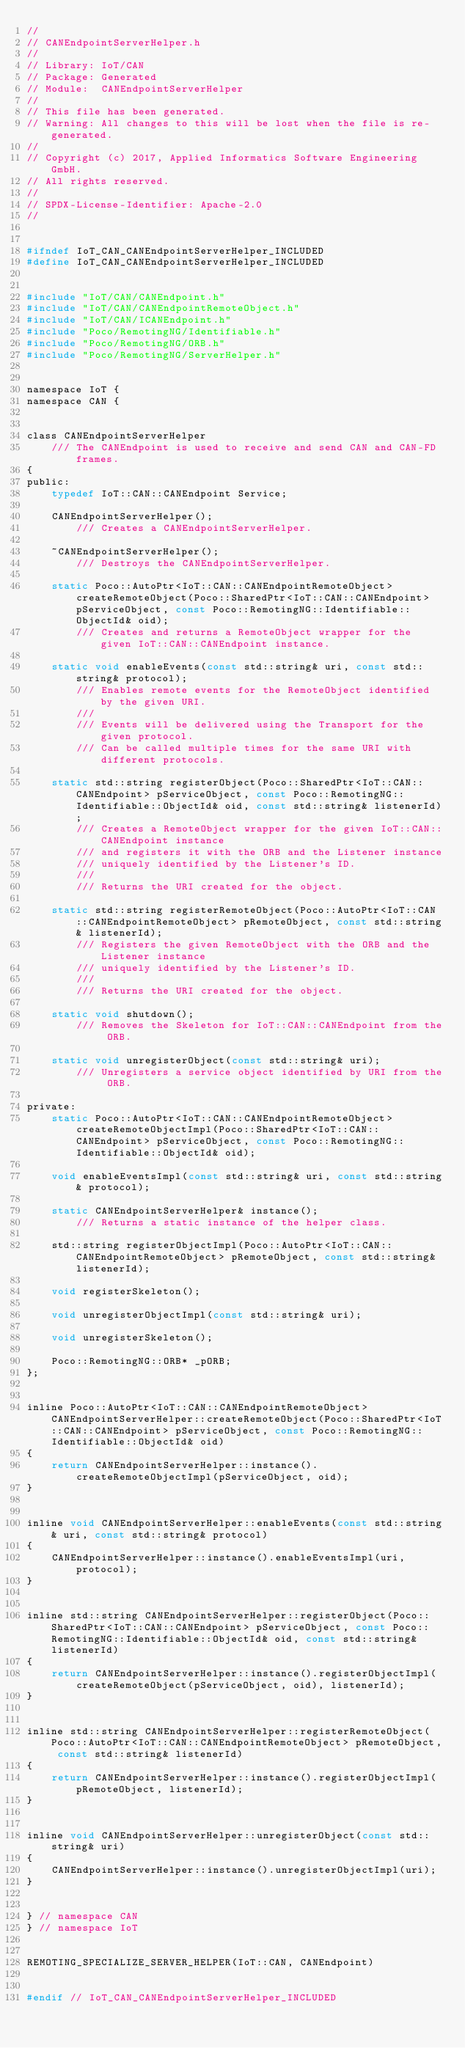<code> <loc_0><loc_0><loc_500><loc_500><_C_>//
// CANEndpointServerHelper.h
//
// Library: IoT/CAN
// Package: Generated
// Module:  CANEndpointServerHelper
//
// This file has been generated.
// Warning: All changes to this will be lost when the file is re-generated.
//
// Copyright (c) 2017, Applied Informatics Software Engineering GmbH.
// All rights reserved.
// 
// SPDX-License-Identifier: Apache-2.0
//


#ifndef IoT_CAN_CANEndpointServerHelper_INCLUDED
#define IoT_CAN_CANEndpointServerHelper_INCLUDED


#include "IoT/CAN/CANEndpoint.h"
#include "IoT/CAN/CANEndpointRemoteObject.h"
#include "IoT/CAN/ICANEndpoint.h"
#include "Poco/RemotingNG/Identifiable.h"
#include "Poco/RemotingNG/ORB.h"
#include "Poco/RemotingNG/ServerHelper.h"


namespace IoT {
namespace CAN {


class CANEndpointServerHelper
	/// The CANEndpoint is used to receive and send CAN and CAN-FD frames.
{
public:
	typedef IoT::CAN::CANEndpoint Service;

	CANEndpointServerHelper();
		/// Creates a CANEndpointServerHelper.

	~CANEndpointServerHelper();
		/// Destroys the CANEndpointServerHelper.

	static Poco::AutoPtr<IoT::CAN::CANEndpointRemoteObject> createRemoteObject(Poco::SharedPtr<IoT::CAN::CANEndpoint> pServiceObject, const Poco::RemotingNG::Identifiable::ObjectId& oid);
		/// Creates and returns a RemoteObject wrapper for the given IoT::CAN::CANEndpoint instance.

	static void enableEvents(const std::string& uri, const std::string& protocol);
		/// Enables remote events for the RemoteObject identified by the given URI.
		///
		/// Events will be delivered using the Transport for the given protocol.
		/// Can be called multiple times for the same URI with different protocols.

	static std::string registerObject(Poco::SharedPtr<IoT::CAN::CANEndpoint> pServiceObject, const Poco::RemotingNG::Identifiable::ObjectId& oid, const std::string& listenerId);
		/// Creates a RemoteObject wrapper for the given IoT::CAN::CANEndpoint instance
		/// and registers it with the ORB and the Listener instance
		/// uniquely identified by the Listener's ID.
		/// 
		///	Returns the URI created for the object.

	static std::string registerRemoteObject(Poco::AutoPtr<IoT::CAN::CANEndpointRemoteObject> pRemoteObject, const std::string& listenerId);
		/// Registers the given RemoteObject with the ORB and the Listener instance
		/// uniquely identified by the Listener's ID.
		/// 
		///	Returns the URI created for the object.

	static void shutdown();
		/// Removes the Skeleton for IoT::CAN::CANEndpoint from the ORB.

	static void unregisterObject(const std::string& uri);
		/// Unregisters a service object identified by URI from the ORB.

private:
	static Poco::AutoPtr<IoT::CAN::CANEndpointRemoteObject> createRemoteObjectImpl(Poco::SharedPtr<IoT::CAN::CANEndpoint> pServiceObject, const Poco::RemotingNG::Identifiable::ObjectId& oid);

	void enableEventsImpl(const std::string& uri, const std::string& protocol);

	static CANEndpointServerHelper& instance();
		/// Returns a static instance of the helper class.

	std::string registerObjectImpl(Poco::AutoPtr<IoT::CAN::CANEndpointRemoteObject> pRemoteObject, const std::string& listenerId);

	void registerSkeleton();

	void unregisterObjectImpl(const std::string& uri);

	void unregisterSkeleton();

	Poco::RemotingNG::ORB* _pORB;
};


inline Poco::AutoPtr<IoT::CAN::CANEndpointRemoteObject> CANEndpointServerHelper::createRemoteObject(Poco::SharedPtr<IoT::CAN::CANEndpoint> pServiceObject, const Poco::RemotingNG::Identifiable::ObjectId& oid)
{
	return CANEndpointServerHelper::instance().createRemoteObjectImpl(pServiceObject, oid);
}


inline void CANEndpointServerHelper::enableEvents(const std::string& uri, const std::string& protocol)
{
	CANEndpointServerHelper::instance().enableEventsImpl(uri, protocol);
}


inline std::string CANEndpointServerHelper::registerObject(Poco::SharedPtr<IoT::CAN::CANEndpoint> pServiceObject, const Poco::RemotingNG::Identifiable::ObjectId& oid, const std::string& listenerId)
{
	return CANEndpointServerHelper::instance().registerObjectImpl(createRemoteObject(pServiceObject, oid), listenerId);
}


inline std::string CANEndpointServerHelper::registerRemoteObject(Poco::AutoPtr<IoT::CAN::CANEndpointRemoteObject> pRemoteObject, const std::string& listenerId)
{
	return CANEndpointServerHelper::instance().registerObjectImpl(pRemoteObject, listenerId);
}


inline void CANEndpointServerHelper::unregisterObject(const std::string& uri)
{
	CANEndpointServerHelper::instance().unregisterObjectImpl(uri);
}


} // namespace CAN
} // namespace IoT


REMOTING_SPECIALIZE_SERVER_HELPER(IoT::CAN, CANEndpoint)


#endif // IoT_CAN_CANEndpointServerHelper_INCLUDED

</code> 